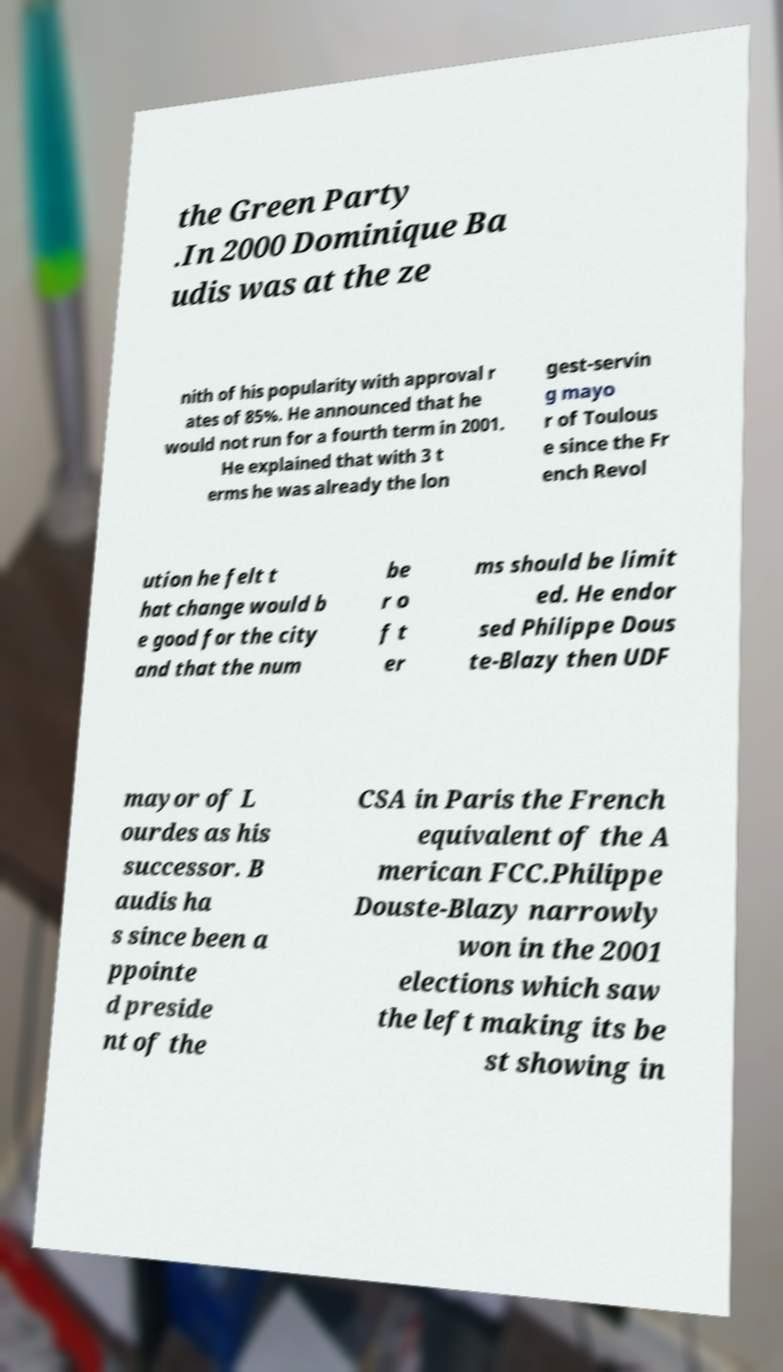I need the written content from this picture converted into text. Can you do that? the Green Party .In 2000 Dominique Ba udis was at the ze nith of his popularity with approval r ates of 85%. He announced that he would not run for a fourth term in 2001. He explained that with 3 t erms he was already the lon gest-servin g mayo r of Toulous e since the Fr ench Revol ution he felt t hat change would b e good for the city and that the num be r o f t er ms should be limit ed. He endor sed Philippe Dous te-Blazy then UDF mayor of L ourdes as his successor. B audis ha s since been a ppointe d preside nt of the CSA in Paris the French equivalent of the A merican FCC.Philippe Douste-Blazy narrowly won in the 2001 elections which saw the left making its be st showing in 